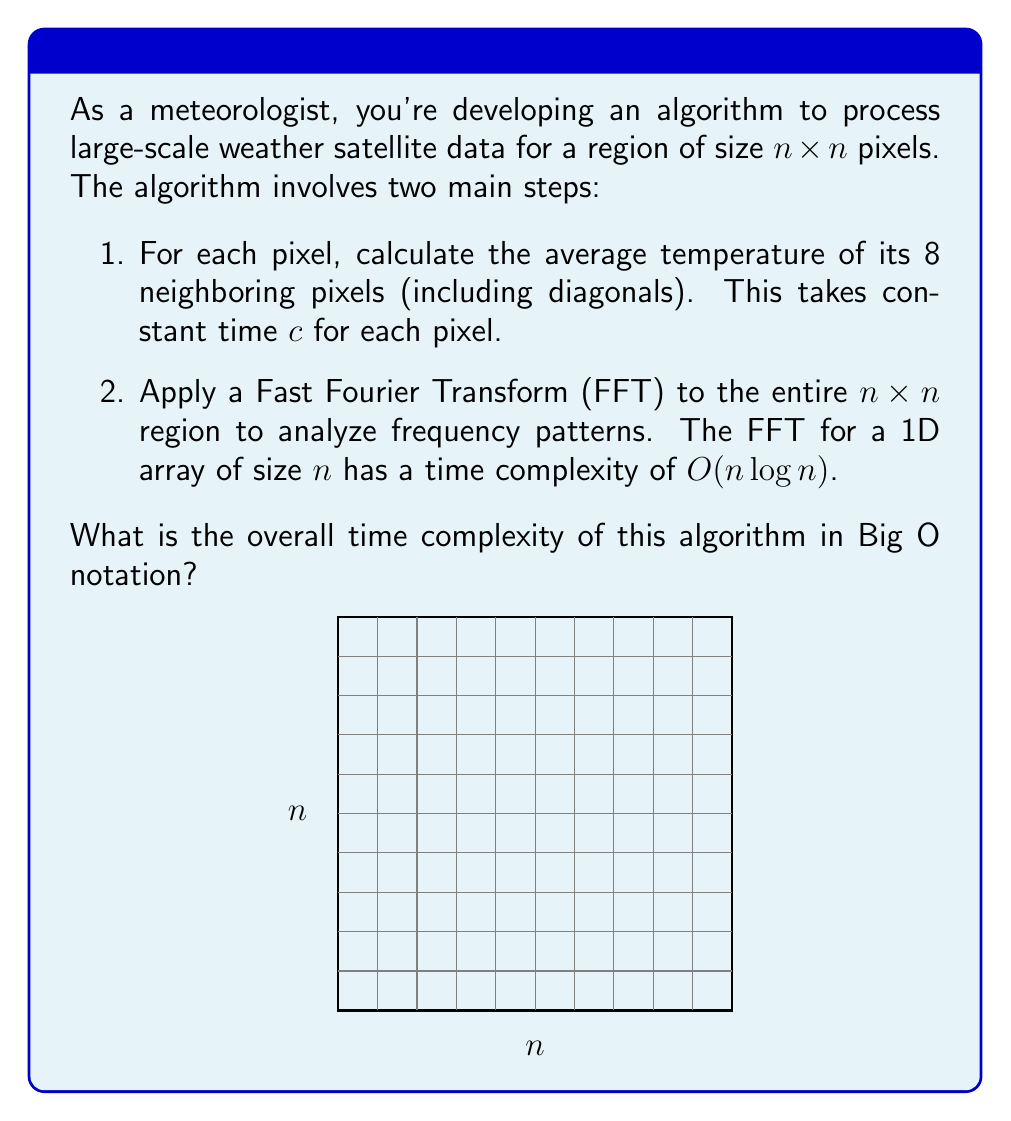Give your solution to this math problem. Let's analyze the time complexity step by step:

1. Calculating average temperature for neighboring pixels:
   - This operation is performed for each pixel in the $n \times n$ grid.
   - Total number of pixels = $n^2$
   - Time for each pixel = constant $c$
   - Total time for this step = $cn^2$
   - Time complexity of this step: $O(n^2)$

2. Applying FFT to the entire region:
   - The FFT is applied to a 2D array of size $n \times n$.
   - For a 2D FFT, we first apply 1D FFT to each row, then to each column.
   - Number of rows = $n$, each row has $n$ elements
   - Time for one row: $O(n \log n)$
   - Time for all rows: $O(n^2 \log n)$
   - Then repeat for columns: another $O(n^2 \log n)$
   - Total time for 2D FFT: $O(n^2 \log n)$

3. Overall time complexity:
   - We add the complexities of both steps:
     $O(n^2) + O(n^2 \log n)$
   - The dominant term is $O(n^2 \log n)$

Therefore, the overall time complexity of the algorithm is $O(n^2 \log n)$.
Answer: $O(n^2 \log n)$ 